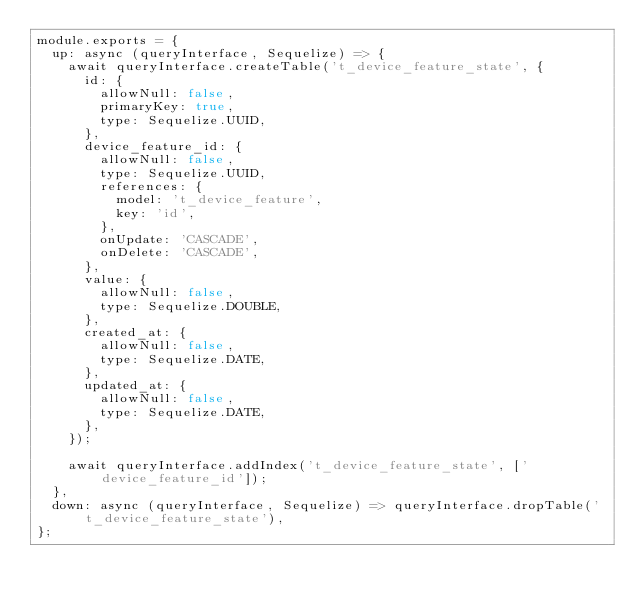Convert code to text. <code><loc_0><loc_0><loc_500><loc_500><_JavaScript_>module.exports = {
  up: async (queryInterface, Sequelize) => {
    await queryInterface.createTable('t_device_feature_state', {
      id: {
        allowNull: false,
        primaryKey: true,
        type: Sequelize.UUID,
      },
      device_feature_id: {
        allowNull: false,
        type: Sequelize.UUID,
        references: {
          model: 't_device_feature',
          key: 'id',
        },
        onUpdate: 'CASCADE',
        onDelete: 'CASCADE',
      },
      value: {
        allowNull: false,
        type: Sequelize.DOUBLE,
      },
      created_at: {
        allowNull: false,
        type: Sequelize.DATE,
      },
      updated_at: {
        allowNull: false,
        type: Sequelize.DATE,
      },
    });

    await queryInterface.addIndex('t_device_feature_state', ['device_feature_id']);
  },
  down: async (queryInterface, Sequelize) => queryInterface.dropTable('t_device_feature_state'),
};
</code> 